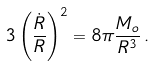<formula> <loc_0><loc_0><loc_500><loc_500>3 \left ( \frac { \dot { R } } { R } \right ) ^ { 2 } = 8 \pi \frac { M _ { o } } { R ^ { 3 } } \, .</formula> 